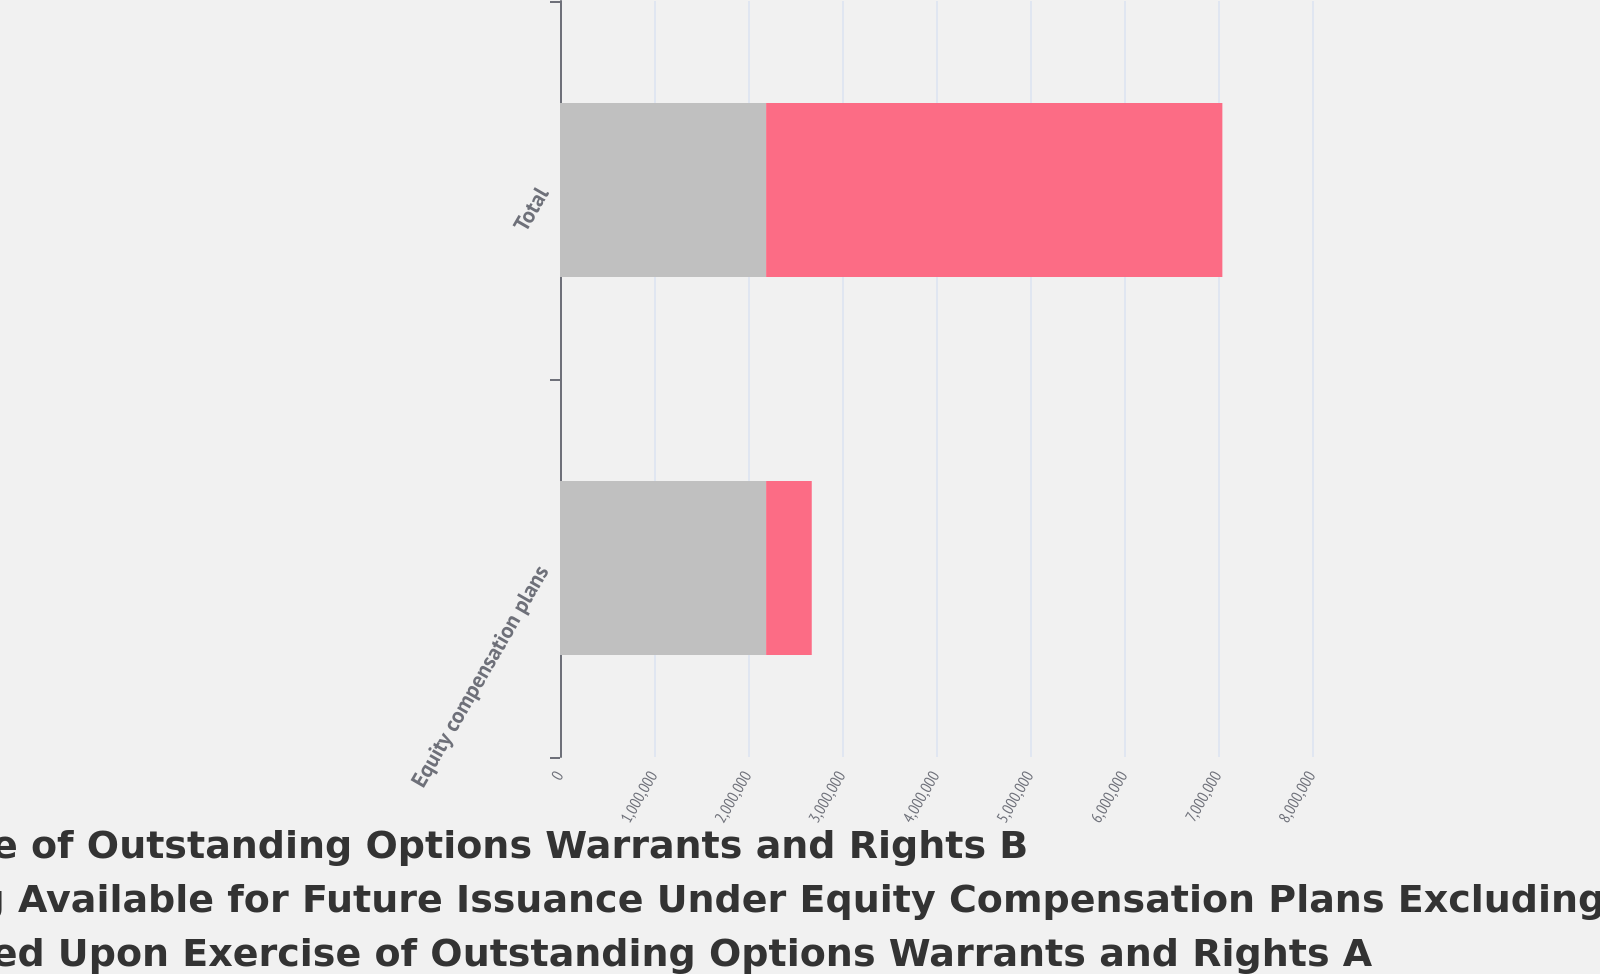Convert chart to OTSL. <chart><loc_0><loc_0><loc_500><loc_500><stacked_bar_chart><ecel><fcel>Equity compensation plans<fcel>Total<nl><fcel>Weighted Average Exercise Price of Outstanding Options Warrants and Rights B<fcel>2.19287e+06<fcel>2.19287e+06<nl><fcel>Number of Securities Remaining Available for Future Issuance Under Equity Compensation Plans Excluding Securities Reflected in Column A C<fcel>6.75<fcel>6.75<nl><fcel>Number of Securities To Be Issued Upon Exercise of Outstanding Options Warrants and Rights A<fcel>485360<fcel>4.8536e+06<nl></chart> 